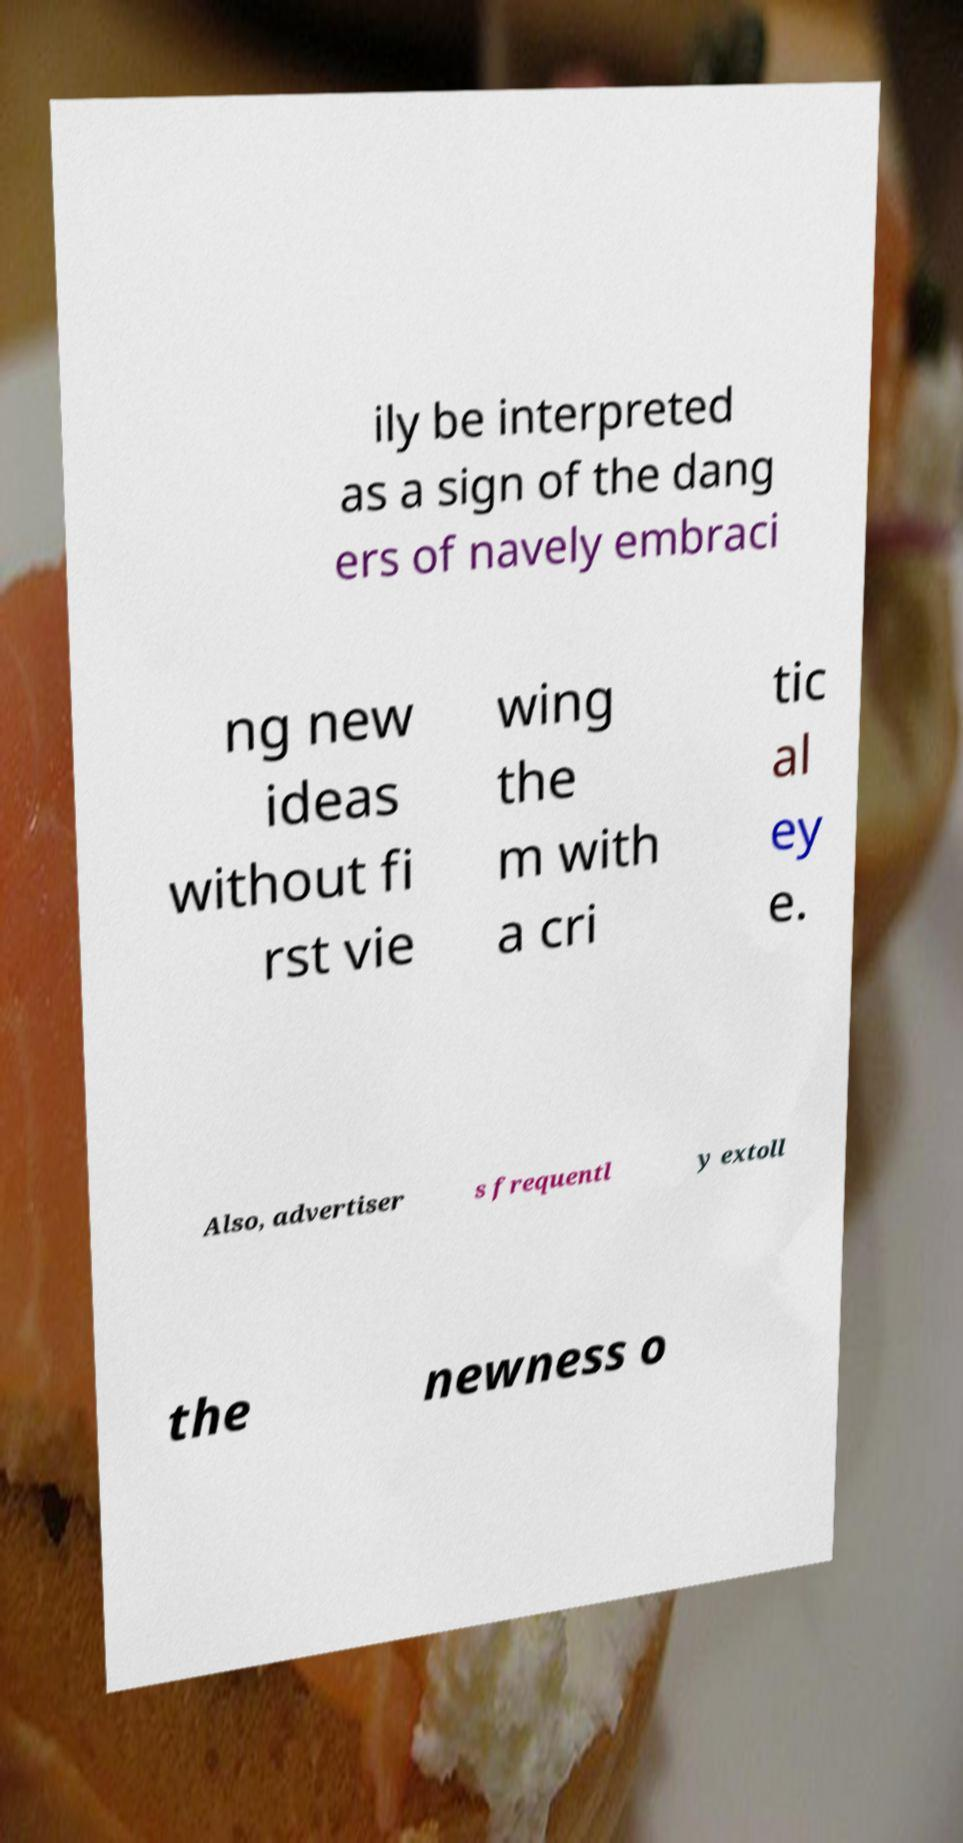Can you read and provide the text displayed in the image?This photo seems to have some interesting text. Can you extract and type it out for me? ily be interpreted as a sign of the dang ers of navely embraci ng new ideas without fi rst vie wing the m with a cri tic al ey e. Also, advertiser s frequentl y extoll the newness o 